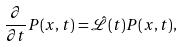Convert formula to latex. <formula><loc_0><loc_0><loc_500><loc_500>\frac { \partial } { \partial t } P ( x , t ) = { \hat { \mathcal { L } } } ( t ) P ( x , t ) ,</formula> 